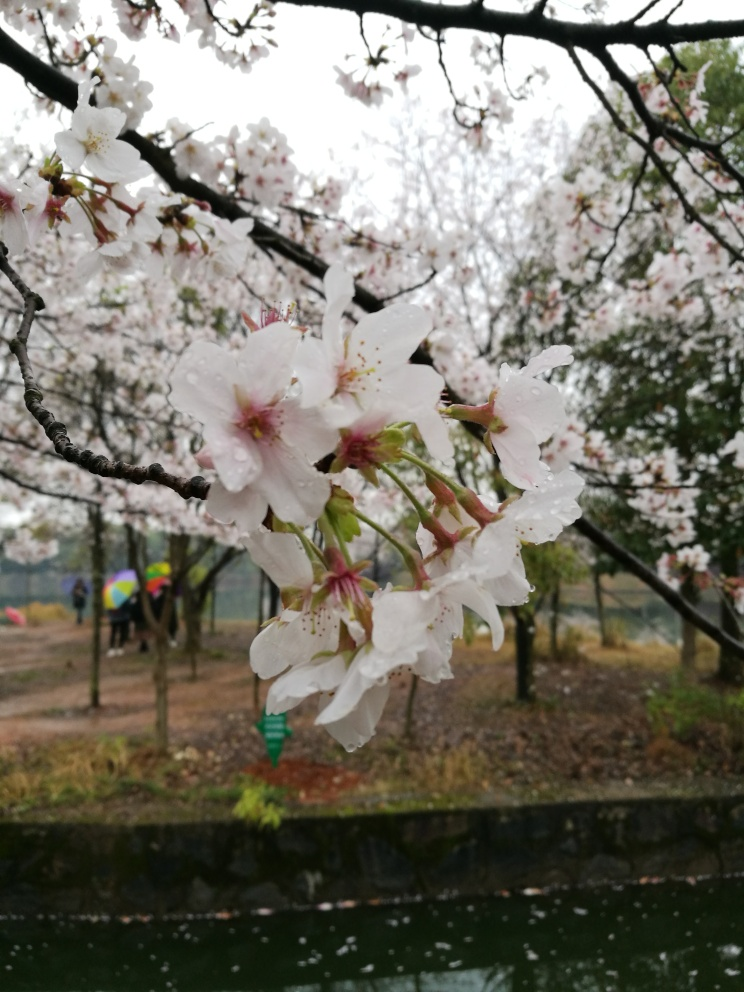Are there any quality issues with this image? Yes, there are a few quality issues with this image. The focus seems to be on the water droplets on the cherry blossoms, making the background slightly blurred, which may or may not have been the photographer's intent. Additionally, the lighting is flat, likely due to overcast weather, which can make the colors appear less vibrant. There's also a slight tilt to the horizon line that can affect the overall composition. 